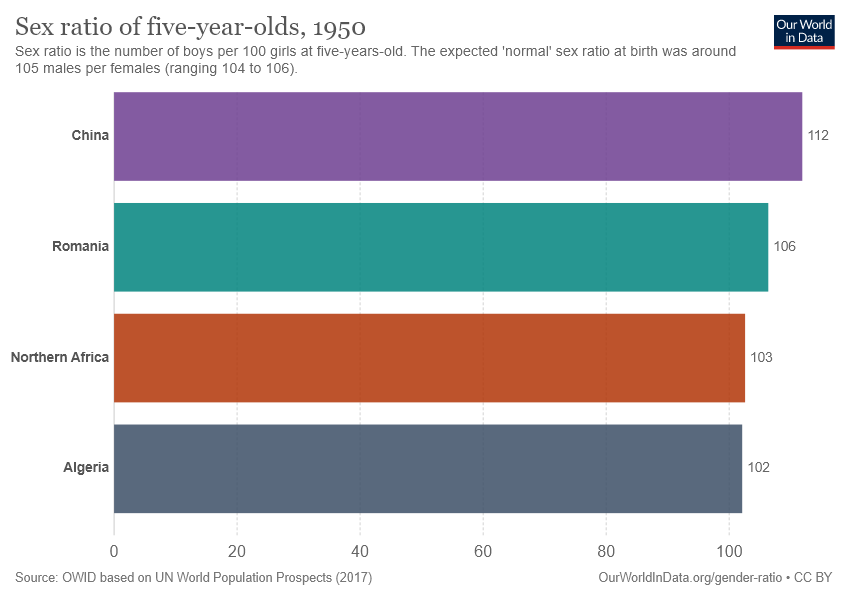Outline some significant characteristics in this image. The highest sex ratio of five-year-old children can be found in China. To find the average and sum of two middle values in a list [104.5, 209], average and sum should be calculated separately. 